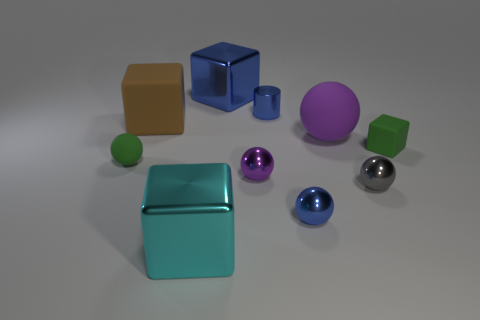Is the color of the small rubber cube the same as the tiny matte ball?
Provide a succinct answer. Yes. There is a large object behind the tiny blue shiny object behind the brown cube; is there a green rubber cube that is to the right of it?
Your response must be concise. Yes. How many other things are there of the same material as the cylinder?
Your response must be concise. 5. What number of purple metallic things are there?
Provide a short and direct response. 1. What number of things are either big cyan metallic blocks or purple objects that are behind the tiny rubber cube?
Offer a terse response. 2. Is the size of the rubber cube to the right of the blue block the same as the cyan cube?
Your response must be concise. No. What number of metallic objects are big blue objects or tiny balls?
Give a very brief answer. 4. There is a cube in front of the tiny cube; what size is it?
Make the answer very short. Large. Is the big blue object the same shape as the gray metallic object?
Offer a very short reply. No. What number of big objects are either green blocks or blue metal cylinders?
Your answer should be compact. 0. 